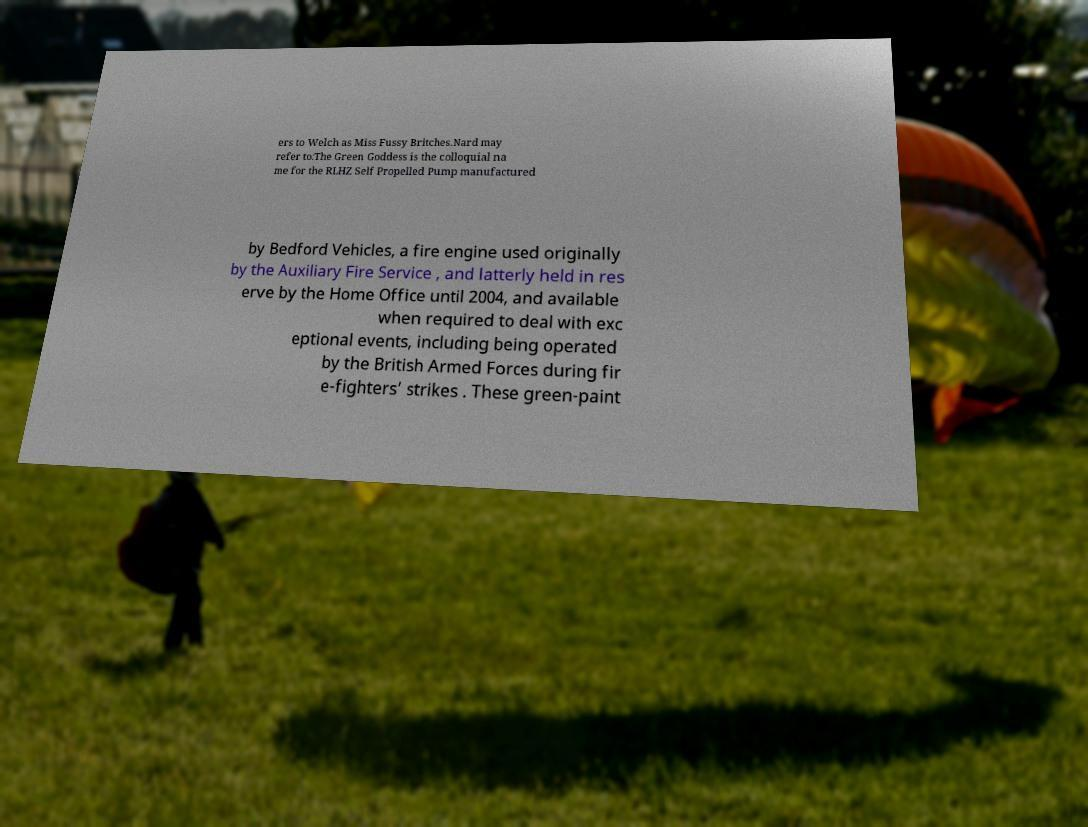Can you read and provide the text displayed in the image?This photo seems to have some interesting text. Can you extract and type it out for me? ers to Welch as Miss Fussy Britches.Nard may refer to:The Green Goddess is the colloquial na me for the RLHZ Self Propelled Pump manufactured by Bedford Vehicles, a fire engine used originally by the Auxiliary Fire Service , and latterly held in res erve by the Home Office until 2004, and available when required to deal with exc eptional events, including being operated by the British Armed Forces during fir e-fighters’ strikes . These green-paint 